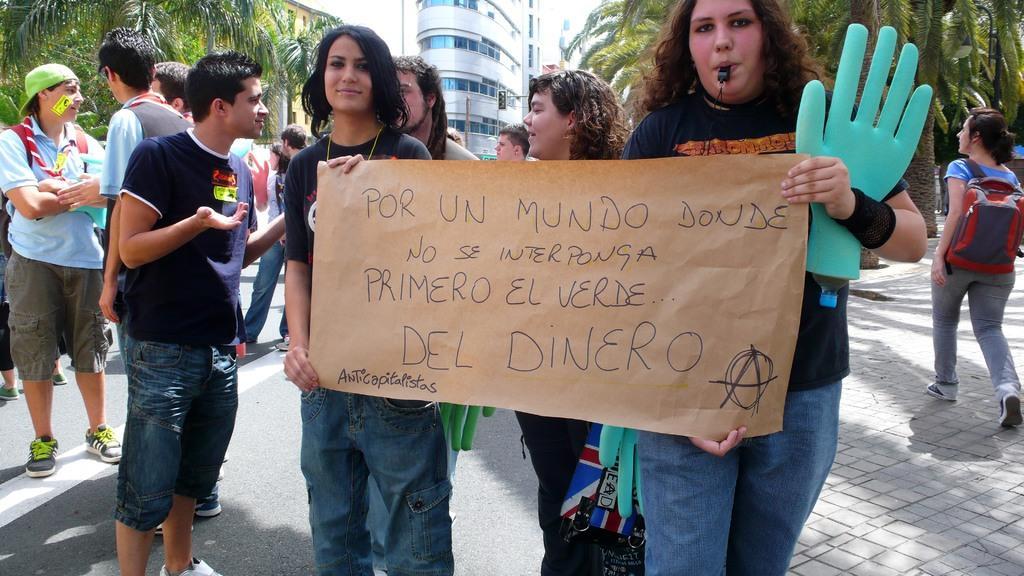Can you describe this image briefly? In this image I can see number of people are standing and I can see few of them are holding hand like things. In the front I can see two women are holding a brown colour paper and on it I can see something is written. On the both side of the image I can see two persons are carrying bags. In the background I can see number of trees, few poles, few signal lights and few buildings. 